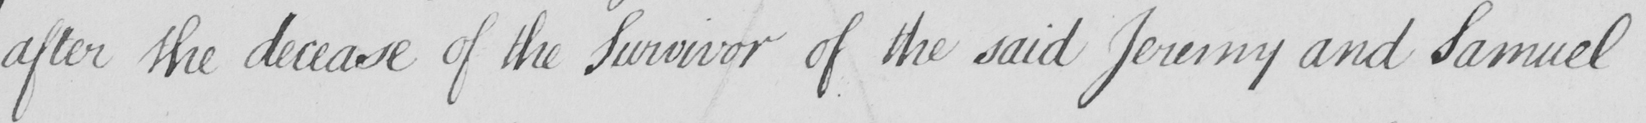Can you tell me what this handwritten text says? after the decease of the Survivor of the said Jeremy and Samuel 